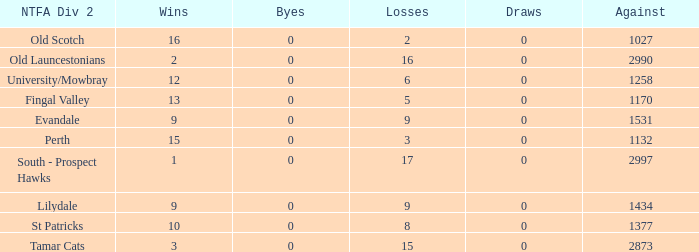What is the lowest number of against of NTFA Div 2 Fingal Valley? 1170.0. 